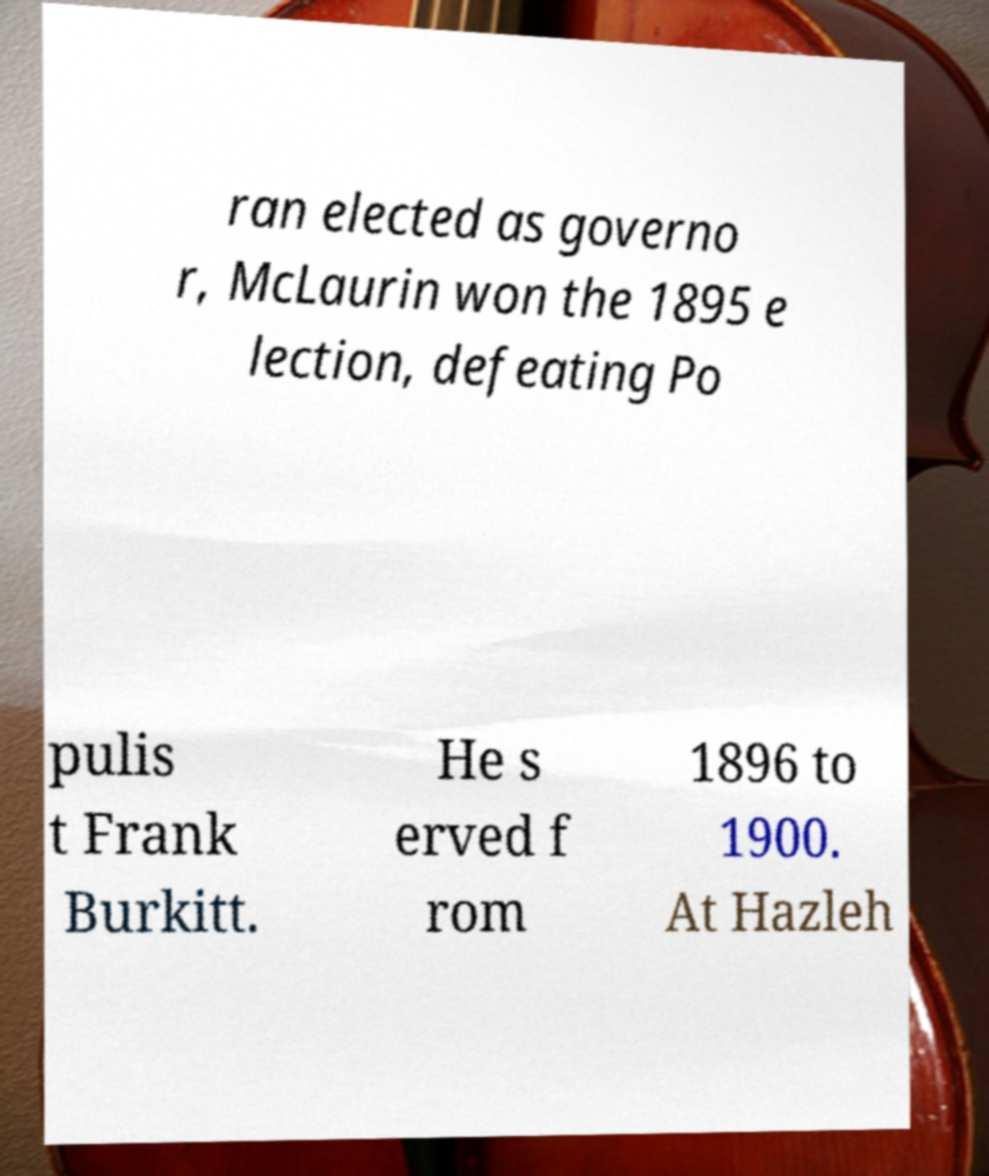What messages or text are displayed in this image? I need them in a readable, typed format. ran elected as governo r, McLaurin won the 1895 e lection, defeating Po pulis t Frank Burkitt. He s erved f rom 1896 to 1900. At Hazleh 